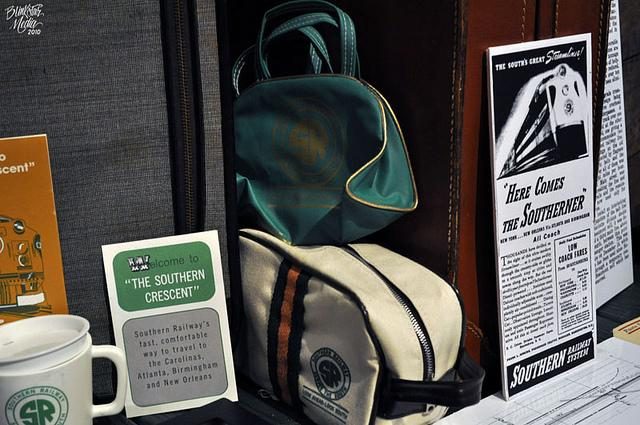What mode of transportation is The Southerner? Please explain your reasoning. train. The transportation is a train. 